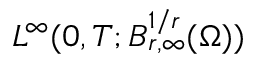Convert formula to latex. <formula><loc_0><loc_0><loc_500><loc_500>L ^ { \infty } ( 0 , T ; B _ { r , \infty } ^ { 1 / r } ( \Omega ) )</formula> 